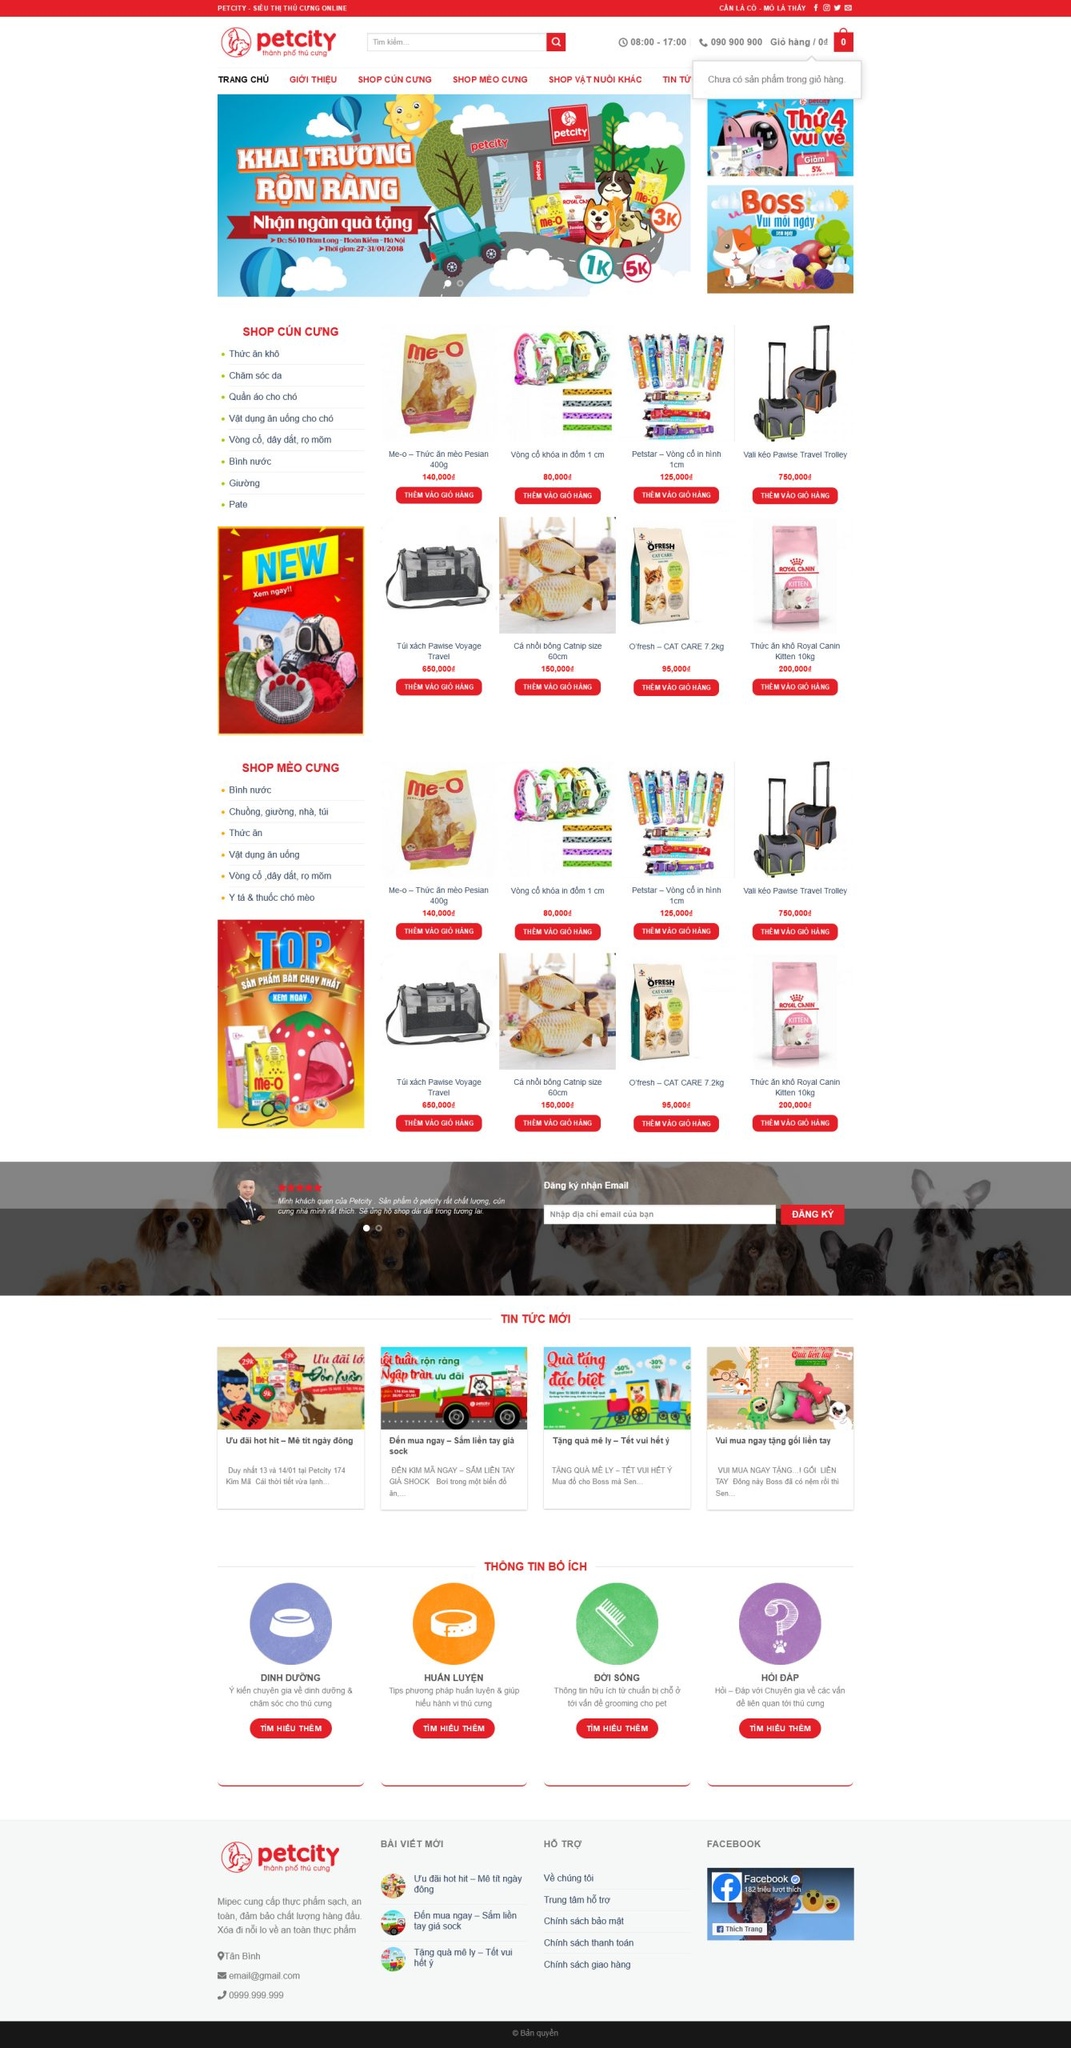Liệt kê 5 ngành nghề, lĩnh vực phù hợp với website này, phân cách các màu sắc bằng dấu phẩy. Chỉ trả về kết quả, phân cách bằng dấy phẩy
 Thú cưng, chăm sóc thú cưng, cửa hàng thú cưng, phụ kiện thú cưng, dinh dưỡng thú cưng 